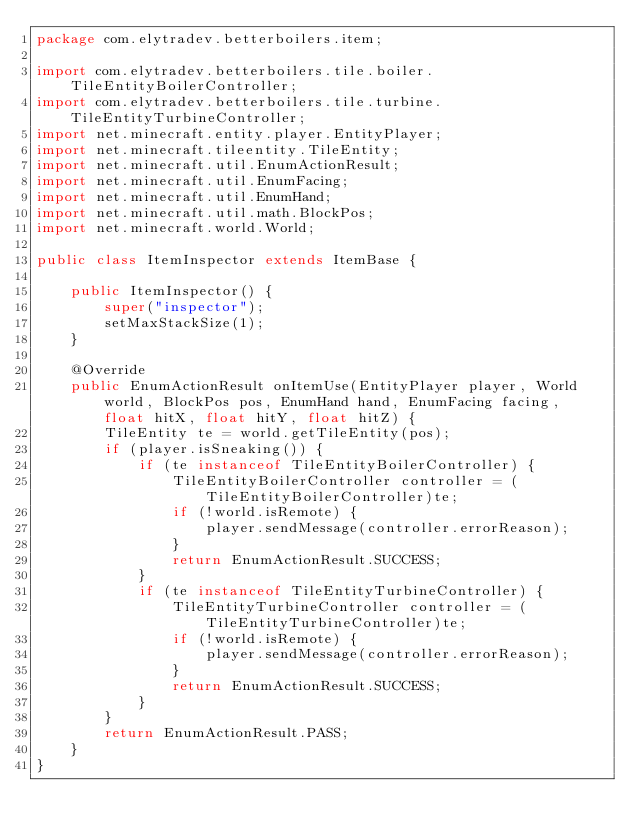Convert code to text. <code><loc_0><loc_0><loc_500><loc_500><_Java_>package com.elytradev.betterboilers.item;

import com.elytradev.betterboilers.tile.boiler.TileEntityBoilerController;
import com.elytradev.betterboilers.tile.turbine.TileEntityTurbineController;
import net.minecraft.entity.player.EntityPlayer;
import net.minecraft.tileentity.TileEntity;
import net.minecraft.util.EnumActionResult;
import net.minecraft.util.EnumFacing;
import net.minecraft.util.EnumHand;
import net.minecraft.util.math.BlockPos;
import net.minecraft.world.World;

public class ItemInspector extends ItemBase {

    public ItemInspector() {
        super("inspector");
        setMaxStackSize(1);
    }

    @Override
    public EnumActionResult onItemUse(EntityPlayer player, World world, BlockPos pos, EnumHand hand, EnumFacing facing, float hitX, float hitY, float hitZ) {
        TileEntity te = world.getTileEntity(pos);
        if (player.isSneaking()) {
            if (te instanceof TileEntityBoilerController) {
                TileEntityBoilerController controller = (TileEntityBoilerController)te;
                if (!world.isRemote) {
                    player.sendMessage(controller.errorReason);
                }
                return EnumActionResult.SUCCESS;
            }
            if (te instanceof TileEntityTurbineController) {
                TileEntityTurbineController controller = (TileEntityTurbineController)te;
                if (!world.isRemote) {
                    player.sendMessage(controller.errorReason);
                }
                return EnumActionResult.SUCCESS;
            }
        }
        return EnumActionResult.PASS;
    }
}
</code> 